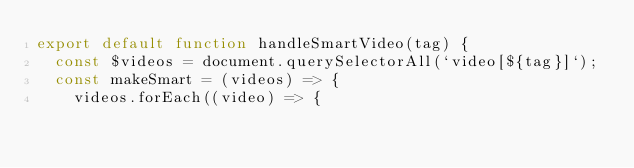<code> <loc_0><loc_0><loc_500><loc_500><_JavaScript_>export default function handleSmartVideo(tag) {
  const $videos = document.querySelectorAll(`video[${tag}]`);
  const makeSmart = (videos) => {
    videos.forEach((video) => {</code> 